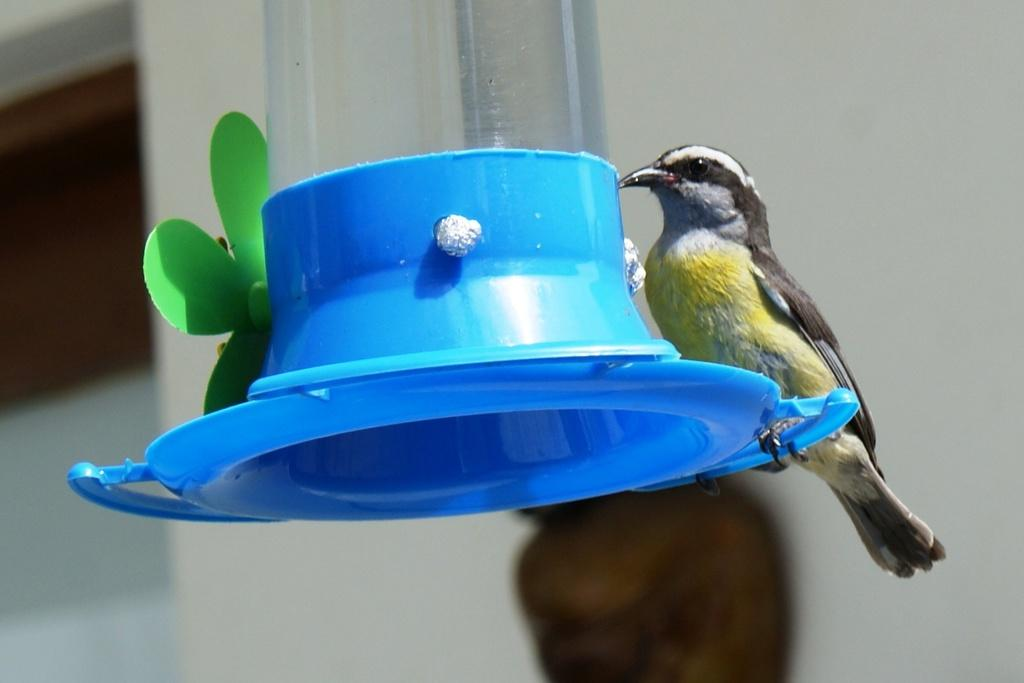What type of animal is in the image? There is a bird in the image. What is the bird sitting on? The bird is on a blue object. What can be seen in the image besides the bird? There is a glass and a green flower visible in the image. What is visible in the background of the image? A wall is visible in the background of the image. How many properties does the bird own in the image? The bird does not own any properties in the image, as it is a bird and not a person. 